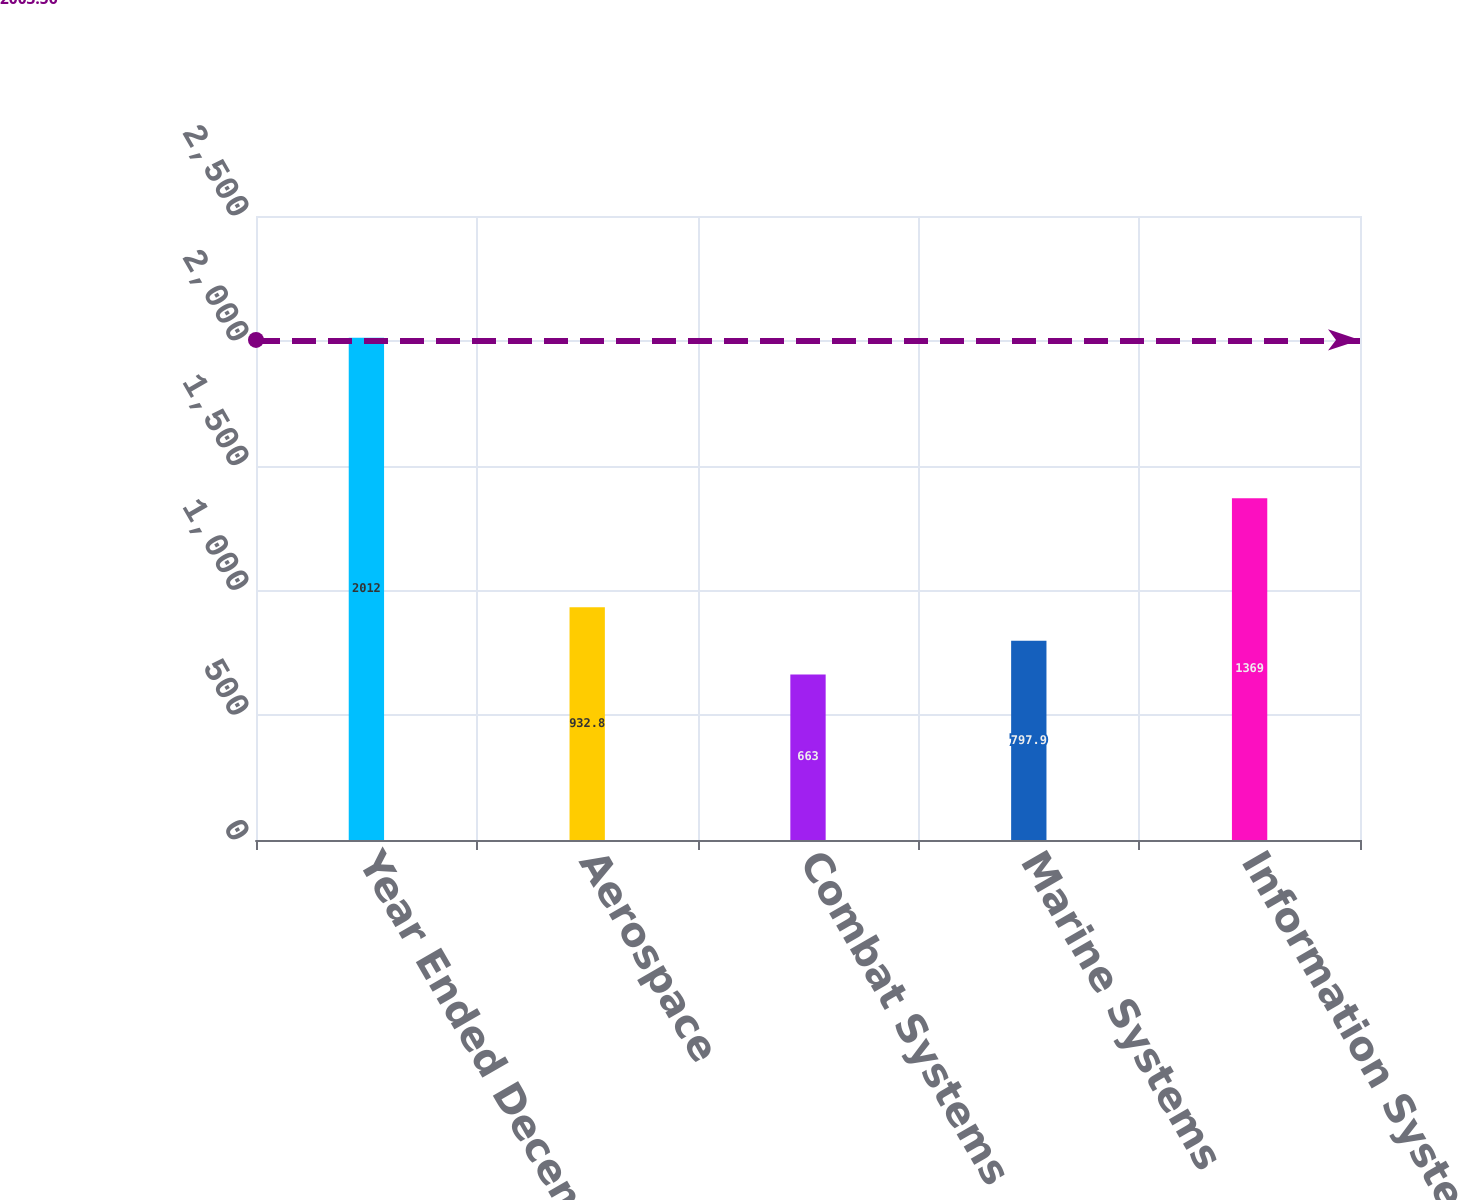Convert chart. <chart><loc_0><loc_0><loc_500><loc_500><bar_chart><fcel>Year Ended December 31<fcel>Aerospace<fcel>Combat Systems<fcel>Marine Systems<fcel>Information Systems and<nl><fcel>2012<fcel>932.8<fcel>663<fcel>797.9<fcel>1369<nl></chart> 